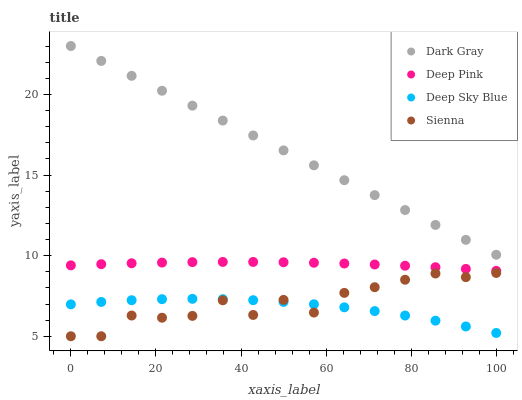Does Deep Sky Blue have the minimum area under the curve?
Answer yes or no. Yes. Does Dark Gray have the maximum area under the curve?
Answer yes or no. Yes. Does Sienna have the minimum area under the curve?
Answer yes or no. No. Does Sienna have the maximum area under the curve?
Answer yes or no. No. Is Dark Gray the smoothest?
Answer yes or no. Yes. Is Sienna the roughest?
Answer yes or no. Yes. Is Deep Pink the smoothest?
Answer yes or no. No. Is Deep Pink the roughest?
Answer yes or no. No. Does Sienna have the lowest value?
Answer yes or no. Yes. Does Deep Pink have the lowest value?
Answer yes or no. No. Does Dark Gray have the highest value?
Answer yes or no. Yes. Does Sienna have the highest value?
Answer yes or no. No. Is Deep Sky Blue less than Deep Pink?
Answer yes or no. Yes. Is Deep Pink greater than Deep Sky Blue?
Answer yes or no. Yes. Does Deep Sky Blue intersect Sienna?
Answer yes or no. Yes. Is Deep Sky Blue less than Sienna?
Answer yes or no. No. Is Deep Sky Blue greater than Sienna?
Answer yes or no. No. Does Deep Sky Blue intersect Deep Pink?
Answer yes or no. No. 